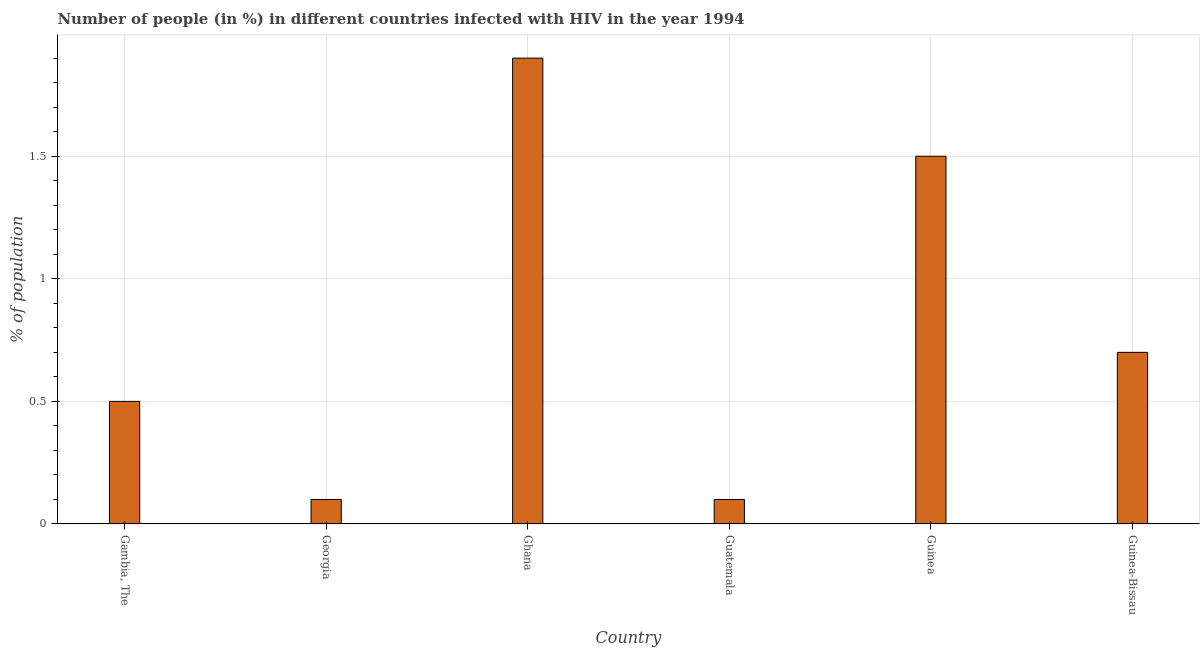Does the graph contain any zero values?
Ensure brevity in your answer.  No. Does the graph contain grids?
Make the answer very short. Yes. What is the title of the graph?
Provide a short and direct response. Number of people (in %) in different countries infected with HIV in the year 1994. What is the label or title of the Y-axis?
Ensure brevity in your answer.  % of population. Across all countries, what is the maximum number of people infected with hiv?
Ensure brevity in your answer.  1.9. In which country was the number of people infected with hiv maximum?
Your answer should be very brief. Ghana. In which country was the number of people infected with hiv minimum?
Give a very brief answer. Georgia. In how many countries, is the number of people infected with hiv greater than 1.3 %?
Give a very brief answer. 2. What is the difference between the highest and the lowest number of people infected with hiv?
Offer a very short reply. 1.8. In how many countries, is the number of people infected with hiv greater than the average number of people infected with hiv taken over all countries?
Make the answer very short. 2. Are all the bars in the graph horizontal?
Keep it short and to the point. No. What is the % of population in Gambia, The?
Provide a short and direct response. 0.5. What is the % of population of Guatemala?
Your answer should be very brief. 0.1. What is the % of population of Guinea?
Make the answer very short. 1.5. What is the % of population of Guinea-Bissau?
Keep it short and to the point. 0.7. What is the difference between the % of population in Gambia, The and Georgia?
Keep it short and to the point. 0.4. What is the difference between the % of population in Gambia, The and Ghana?
Ensure brevity in your answer.  -1.4. What is the difference between the % of population in Gambia, The and Guinea?
Your answer should be compact. -1. What is the difference between the % of population in Gambia, The and Guinea-Bissau?
Offer a terse response. -0.2. What is the difference between the % of population in Georgia and Ghana?
Your response must be concise. -1.8. What is the difference between the % of population in Georgia and Guinea?
Offer a terse response. -1.4. What is the difference between the % of population in Georgia and Guinea-Bissau?
Keep it short and to the point. -0.6. What is the difference between the % of population in Ghana and Guatemala?
Provide a short and direct response. 1.8. What is the difference between the % of population in Ghana and Guinea?
Provide a short and direct response. 0.4. What is the difference between the % of population in Ghana and Guinea-Bissau?
Keep it short and to the point. 1.2. What is the difference between the % of population in Guatemala and Guinea?
Your answer should be very brief. -1.4. What is the difference between the % of population in Guinea and Guinea-Bissau?
Keep it short and to the point. 0.8. What is the ratio of the % of population in Gambia, The to that in Ghana?
Provide a succinct answer. 0.26. What is the ratio of the % of population in Gambia, The to that in Guinea?
Provide a short and direct response. 0.33. What is the ratio of the % of population in Gambia, The to that in Guinea-Bissau?
Give a very brief answer. 0.71. What is the ratio of the % of population in Georgia to that in Ghana?
Give a very brief answer. 0.05. What is the ratio of the % of population in Georgia to that in Guinea?
Offer a very short reply. 0.07. What is the ratio of the % of population in Georgia to that in Guinea-Bissau?
Provide a short and direct response. 0.14. What is the ratio of the % of population in Ghana to that in Guinea?
Offer a very short reply. 1.27. What is the ratio of the % of population in Ghana to that in Guinea-Bissau?
Keep it short and to the point. 2.71. What is the ratio of the % of population in Guatemala to that in Guinea?
Give a very brief answer. 0.07. What is the ratio of the % of population in Guatemala to that in Guinea-Bissau?
Your answer should be very brief. 0.14. What is the ratio of the % of population in Guinea to that in Guinea-Bissau?
Your answer should be very brief. 2.14. 